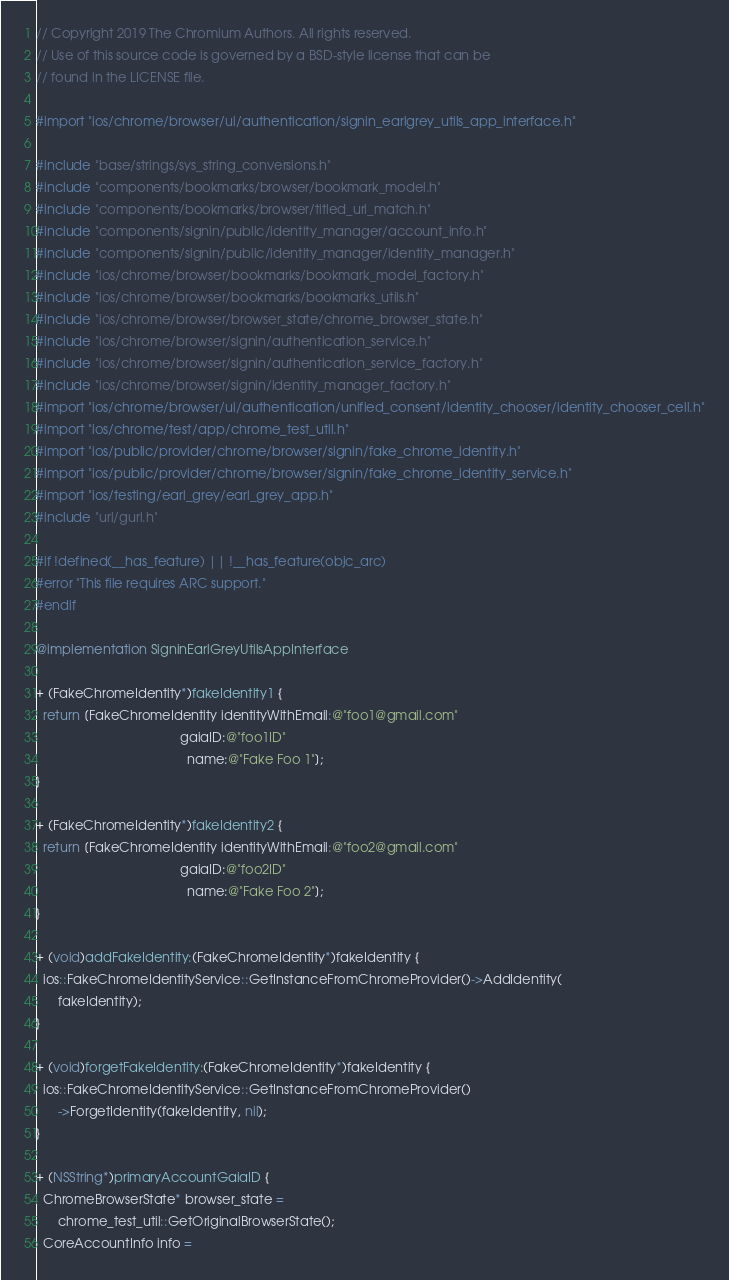<code> <loc_0><loc_0><loc_500><loc_500><_ObjectiveC_>// Copyright 2019 The Chromium Authors. All rights reserved.
// Use of this source code is governed by a BSD-style license that can be
// found in the LICENSE file.

#import "ios/chrome/browser/ui/authentication/signin_earlgrey_utils_app_interface.h"

#include "base/strings/sys_string_conversions.h"
#include "components/bookmarks/browser/bookmark_model.h"
#include "components/bookmarks/browser/titled_url_match.h"
#include "components/signin/public/identity_manager/account_info.h"
#include "components/signin/public/identity_manager/identity_manager.h"
#include "ios/chrome/browser/bookmarks/bookmark_model_factory.h"
#include "ios/chrome/browser/bookmarks/bookmarks_utils.h"
#include "ios/chrome/browser/browser_state/chrome_browser_state.h"
#include "ios/chrome/browser/signin/authentication_service.h"
#include "ios/chrome/browser/signin/authentication_service_factory.h"
#include "ios/chrome/browser/signin/identity_manager_factory.h"
#import "ios/chrome/browser/ui/authentication/unified_consent/identity_chooser/identity_chooser_cell.h"
#import "ios/chrome/test/app/chrome_test_util.h"
#import "ios/public/provider/chrome/browser/signin/fake_chrome_identity.h"
#import "ios/public/provider/chrome/browser/signin/fake_chrome_identity_service.h"
#import "ios/testing/earl_grey/earl_grey_app.h"
#include "url/gurl.h"

#if !defined(__has_feature) || !__has_feature(objc_arc)
#error "This file requires ARC support."
#endif

@implementation SigninEarlGreyUtilsAppInterface

+ (FakeChromeIdentity*)fakeIdentity1 {
  return [FakeChromeIdentity identityWithEmail:@"foo1@gmail.com"
                                        gaiaID:@"foo1ID"
                                          name:@"Fake Foo 1"];
}

+ (FakeChromeIdentity*)fakeIdentity2 {
  return [FakeChromeIdentity identityWithEmail:@"foo2@gmail.com"
                                        gaiaID:@"foo2ID"
                                          name:@"Fake Foo 2"];
}

+ (void)addFakeIdentity:(FakeChromeIdentity*)fakeIdentity {
  ios::FakeChromeIdentityService::GetInstanceFromChromeProvider()->AddIdentity(
      fakeIdentity);
}

+ (void)forgetFakeIdentity:(FakeChromeIdentity*)fakeIdentity {
  ios::FakeChromeIdentityService::GetInstanceFromChromeProvider()
      ->ForgetIdentity(fakeIdentity, nil);
}

+ (NSString*)primaryAccountGaiaID {
  ChromeBrowserState* browser_state =
      chrome_test_util::GetOriginalBrowserState();
  CoreAccountInfo info =</code> 